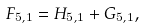<formula> <loc_0><loc_0><loc_500><loc_500>F _ { 5 , 1 } = H _ { 5 , 1 } + G _ { 5 , 1 } ,</formula> 